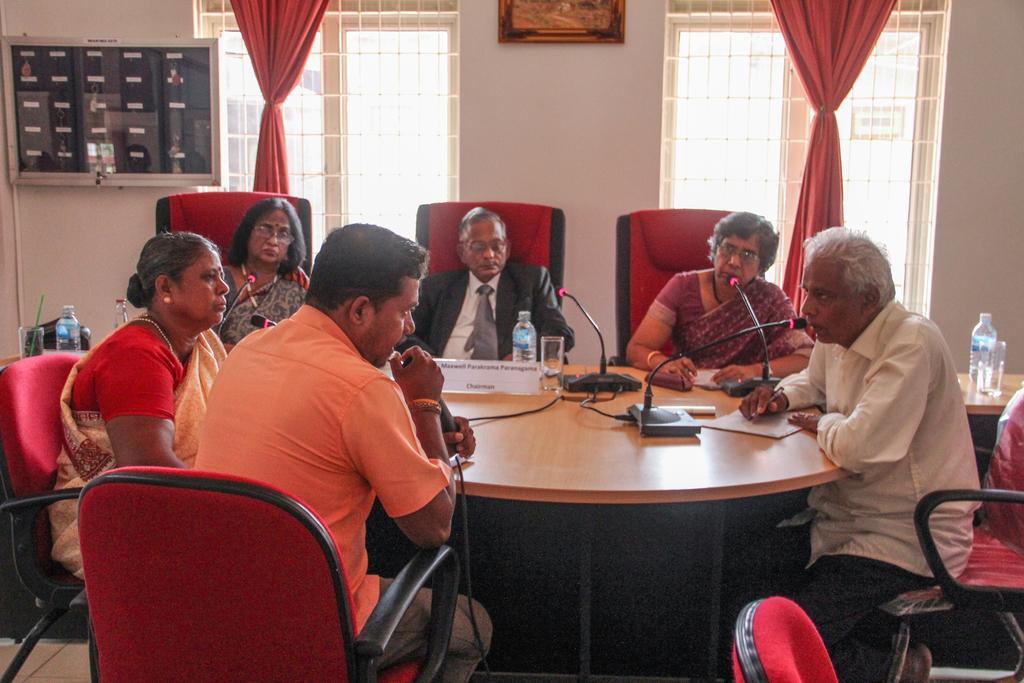Please provide a concise description of this image. In the image we can see there are people who are sitting on chair and a person is holding mic in his hand. On table there is mic with a stand there is paper and a man is holding pen and on table there is water bottle and glass. Behind near the windows there are red colour curtains. 